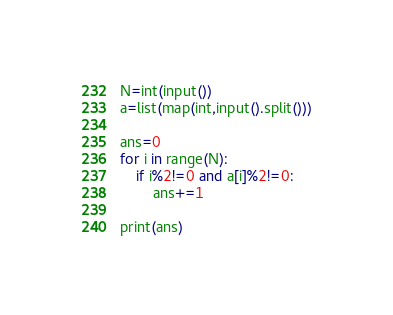<code> <loc_0><loc_0><loc_500><loc_500><_Python_>N=int(input())
a=list(map(int,input().split()))
 
ans=0
for i in range(N):
    if i%2!=0 and a[i]%2!=0:
        ans+=1
        
print(ans)</code> 